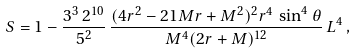<formula> <loc_0><loc_0><loc_500><loc_500>S = 1 - \frac { 3 ^ { 3 } \, 2 ^ { 1 0 } } { 5 ^ { 2 } } \, \frac { ( 4 r ^ { 2 } - 2 1 M r + M ^ { 2 } ) ^ { 2 } r ^ { 4 } \, \sin ^ { 4 } \theta } { M ^ { 4 } ( 2 r + M ) ^ { 1 2 } } \, L ^ { 4 } \, ,</formula> 